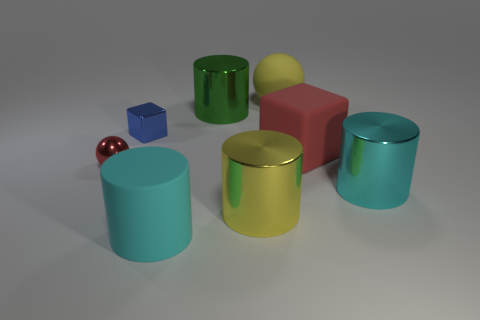Can you describe the colors of the objects seen in this image? Certainly! The image showcases a variety of vibrant colors. There’s a tiny blue cube, a green cylindrical object, a red cuboid shape, two teal cylinders, a gold-colored cylinder, and a small red sphere. Each object's color contributes to a visually appealing assortment. 